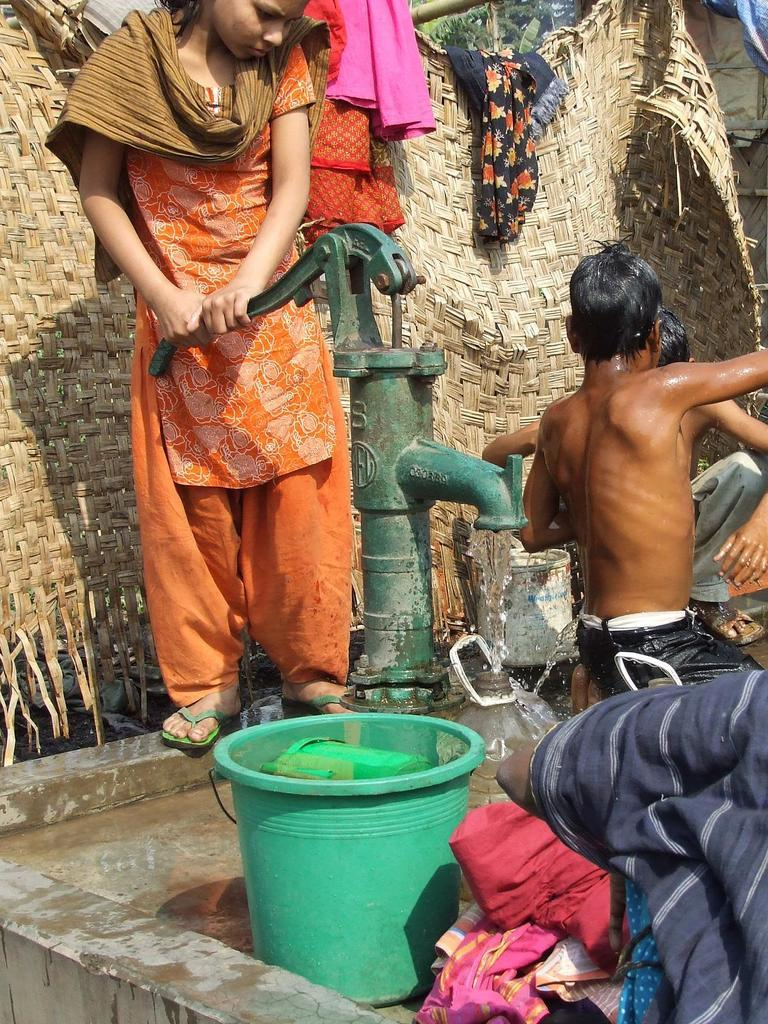What is the main focus of the image? There are people in the center of the image. What objects can be seen near the people? There is a bucket and a mug in the image. What is the liquid in the bucket and mug? There is water in the image. What are the people doing with the water? It is not clear from the image what the people are doing with the water. What can be seen in the background of the image? There are trees and other objects in the background of the image. How does the light affect the water in the image? There is no mention of light in the image, so it is not possible to determine how it affects the water. 